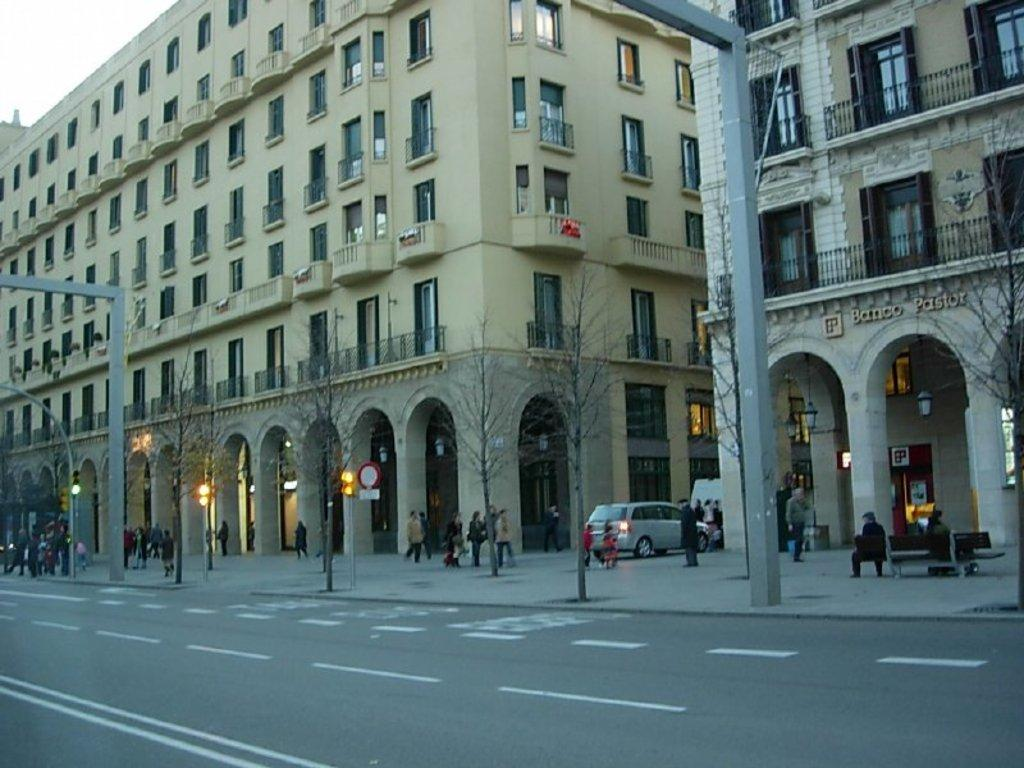What type of structure is visible in the image? There is a building in the image. What is located in front of the building? There are trees and a road in front of the building. Can you describe the person in the image? A person is walking in front of the building. What is the position of the vehicle in the image? A vehicle is parked between the building. What type of steam is coming out of the sack in the image? There is no sack or steam present in the image. 